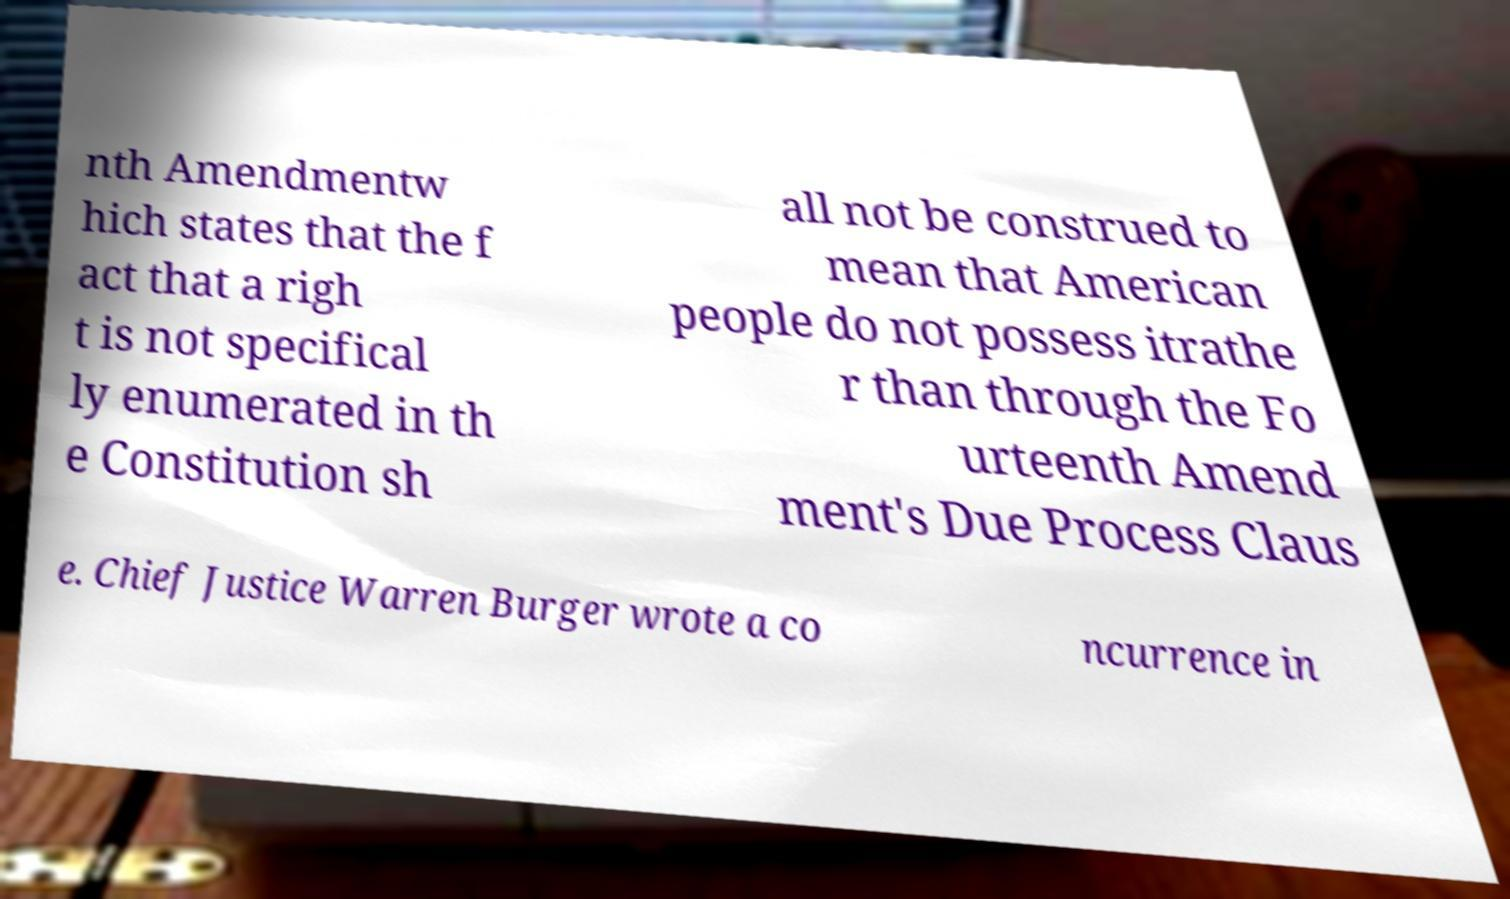What messages or text are displayed in this image? I need them in a readable, typed format. nth Amendmentw hich states that the f act that a righ t is not specifical ly enumerated in th e Constitution sh all not be construed to mean that American people do not possess itrathe r than through the Fo urteenth Amend ment's Due Process Claus e. Chief Justice Warren Burger wrote a co ncurrence in 